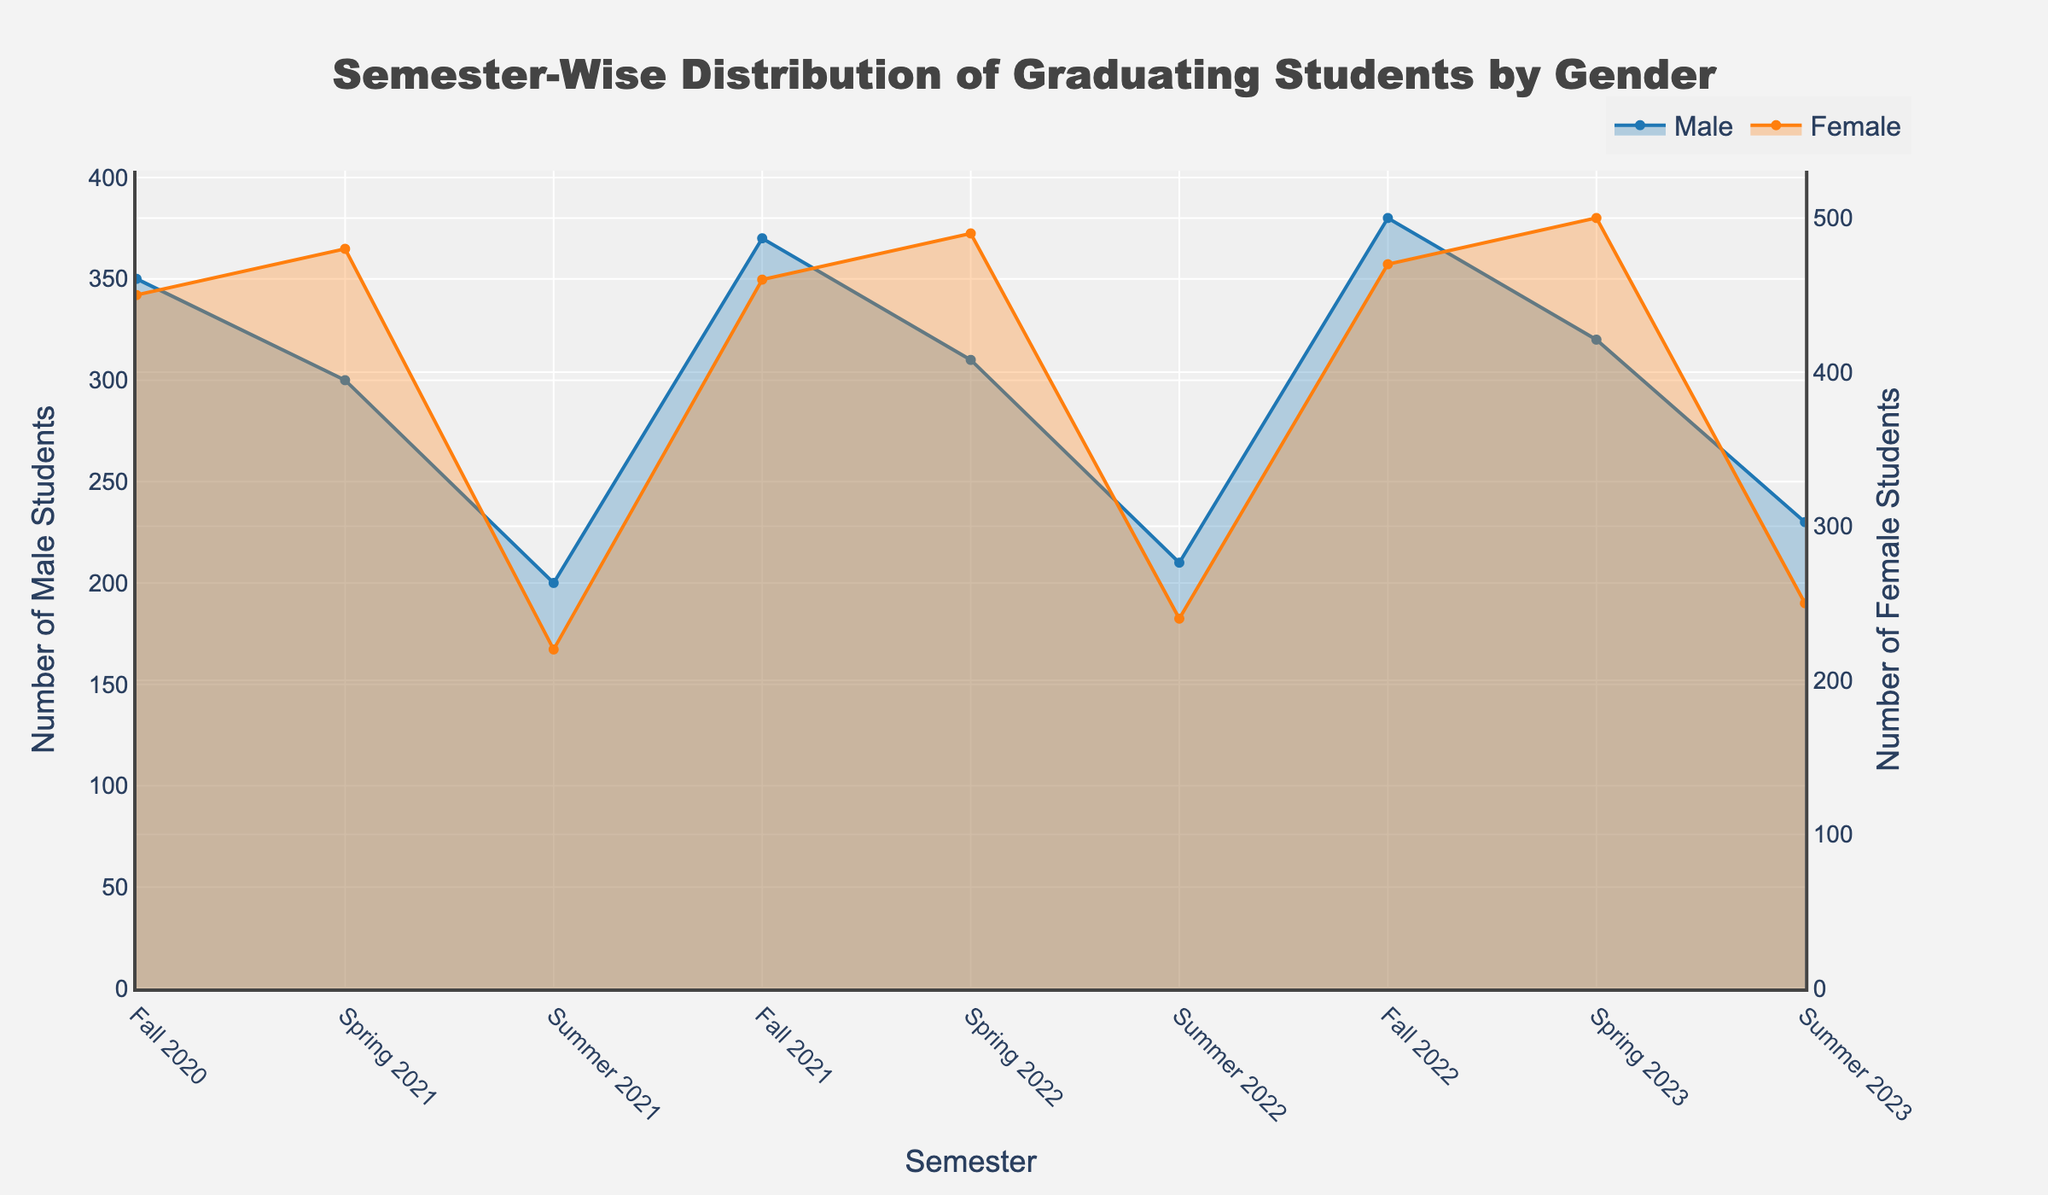What's the title of the chart? The title is displayed at the top center of the figure and reads "Semester-Wise Distribution of Graduating Students by Gender".
Answer: Semester-Wise Distribution of Graduating Students by Gender How many semesters are displayed in the chart? Counting the unique semester labels on the x-axis, you can see that the chart covers "Fall 2020" to "Summer 2023", indicating 9 semesters in total.
Answer: 9 Which semester has the highest number of female students graduating? By comparing the heights of the steps for female students across all semesters, the highest point is in "Spring 2023" with 500 female graduates.
Answer: Spring 2023 What is the difference in the number of male graduates between Fall 2020 and Summer 2023? The number of male graduates in Fall 2020 is 350, and in Summer 2023 it is 230. The difference is calculated as 350 - 230 = 120.
Answer: 120 What semester shows the smallest difference between male and female graduates? To find this, you must compare the differences between male and female counts for each semester. In "Summer 2021", the counts are 200 for males and 220 for females, resulting in the smallest difference of 20.
Answer: Summer 2021 In which semesters did the number of male graduates increase compared to the previous semester? To determine the semesters with an increasing number of male graduates compared to the previous one, compare the counts of subsequent semesters: Fall 2021 (370 vs. 200 in Summer 2021) and Fall 2022 (380 vs. 210 in Summer 2022) are the cases.
Answer: Fall 2021, Fall 2022 What is the average number of female graduates across all displayed semesters? Summing the female counts (450, 480, 220, 460, 490, 240, 470, 500, 250) gives a total of 3560. Dividing by the number of semesters (9) gives the average of 3560/9 ≈ 395.56.
Answer: 395.56 Compare the trends in the number of male and female graduates; is there a consistent trend for either gender? Observing the step patterns, the number of female graduates generally shows an increasing trend with some fluctuations, while the number of male graduates shows more variability and does not follow a consistent upward or downward trend.
Answer: Female increasing, Male variable Between which semesters is there the largest increase in the number of female graduates? The largest increase can be found by calculating the differences between consecutive semesters: between "Spring 2021" (480) and "Fall 2020" (450) the increase is 30, which is the largest jump.
Answer: Spring 2021 to Fall 2020 